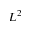<formula> <loc_0><loc_0><loc_500><loc_500>L ^ { 2 }</formula> 